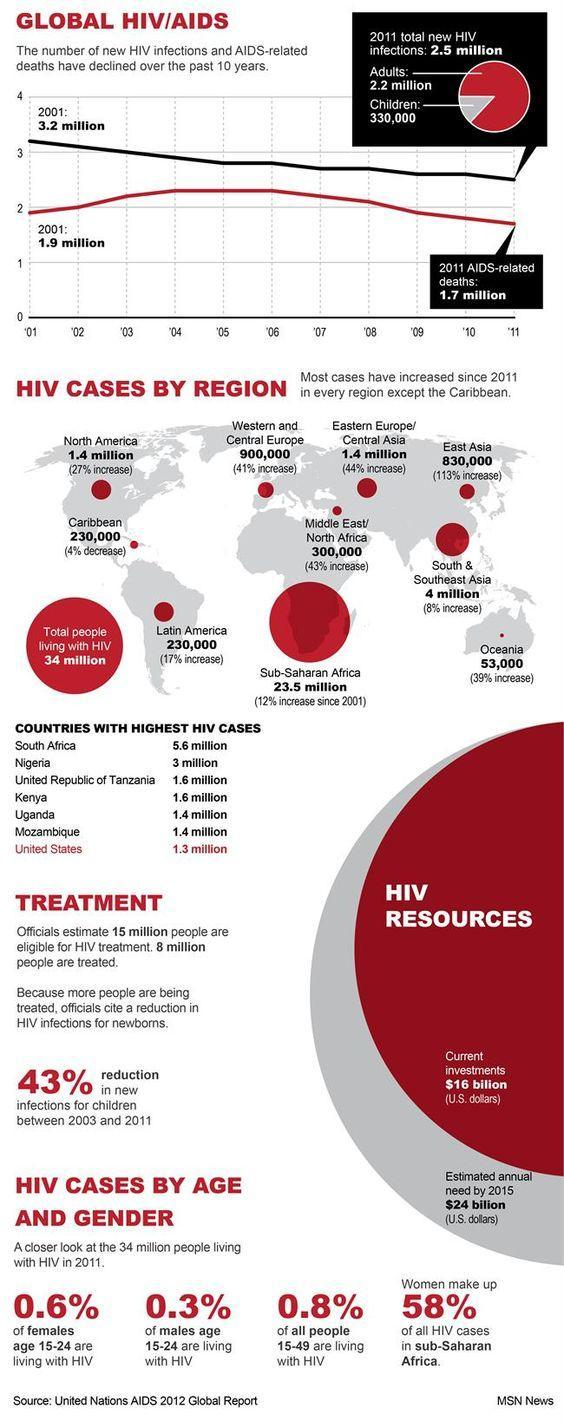What is ranking of Uganda in the list of highest HIV cases, first, third, fifth, or seventh ?
Answer the question with a short phrase. fifth Which region has the highest number of HIV cases? Sub-Saharan Africa What is lowest count of HIV cases by region? 53,000 What is the total number in both the American continents? 1,860,000 What is the difference in percentage increase of countries having a case count of 1.4 million? 17% What is the decline in new HIV infections from 2001 to 2011? 0.7 million Which region has the highest percentage increase of HIV cases? East Asia What is the decline in new HIV deaths from 2001 to 2011? 0.2 million Which regions have the same case counts? Caribbean, Latin America 